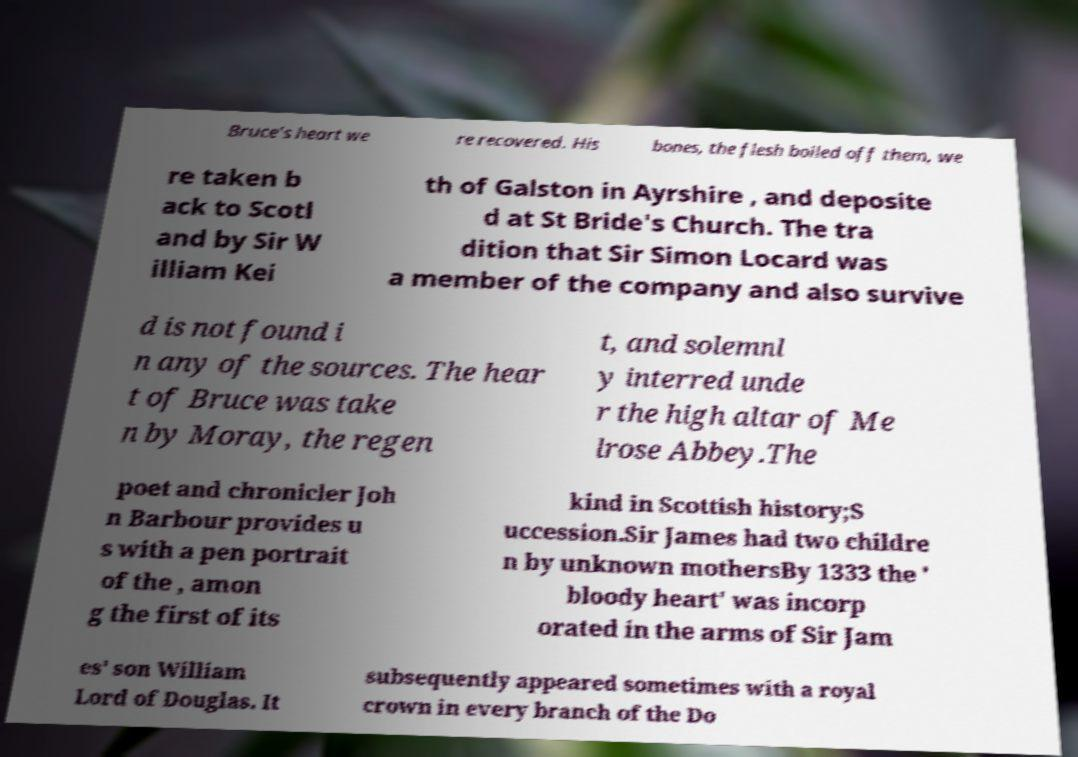Could you extract and type out the text from this image? Bruce's heart we re recovered. His bones, the flesh boiled off them, we re taken b ack to Scotl and by Sir W illiam Kei th of Galston in Ayrshire , and deposite d at St Bride's Church. The tra dition that Sir Simon Locard was a member of the company and also survive d is not found i n any of the sources. The hear t of Bruce was take n by Moray, the regen t, and solemnl y interred unde r the high altar of Me lrose Abbey.The poet and chronicler Joh n Barbour provides u s with a pen portrait of the , amon g the first of its kind in Scottish history;S uccession.Sir James had two childre n by unknown mothersBy 1333 the ' bloody heart' was incorp orated in the arms of Sir Jam es' son William Lord of Douglas. It subsequently appeared sometimes with a royal crown in every branch of the Do 